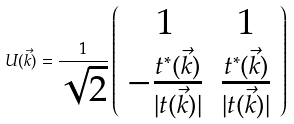Convert formula to latex. <formula><loc_0><loc_0><loc_500><loc_500>U ( \vec { k } ) = \frac { 1 } { \sqrt { 2 } } \left ( \begin{array} { c c } 1 & 1 \\ - \frac { t ^ { * } ( \vec { k } ) } { | t ( \vec { k } ) | } & \frac { t ^ { * } ( \vec { k } ) } { | t ( \vec { k } ) | } \end{array} \right )</formula> 